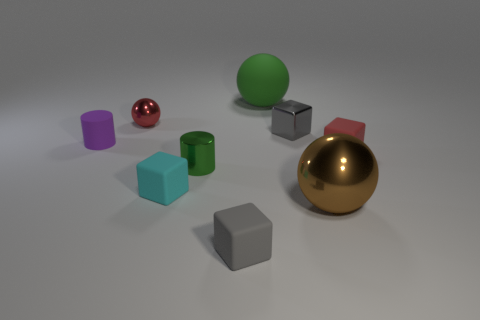What is the material of the green thing that is the same shape as the large brown metallic thing?
Provide a short and direct response. Rubber. What is the size of the sphere that is in front of the red object that is behind the small purple rubber cylinder?
Keep it short and to the point. Large. Is there a big green sphere?
Make the answer very short. Yes. There is a thing that is left of the small cyan rubber thing and on the right side of the small purple cylinder; what material is it?
Keep it short and to the point. Metal. Are there more tiny red shiny balls behind the large green ball than objects in front of the green shiny object?
Keep it short and to the point. No. Is there a yellow sphere of the same size as the cyan block?
Keep it short and to the point. No. There is a gray thing on the right side of the green thing behind the red thing that is in front of the small red ball; how big is it?
Provide a succinct answer. Small. What color is the tiny metallic cube?
Your answer should be very brief. Gray. Is the number of green spheres that are in front of the green rubber sphere greater than the number of tiny rubber objects?
Provide a succinct answer. No. There is a brown shiny ball; what number of rubber cylinders are on the right side of it?
Provide a short and direct response. 0. 